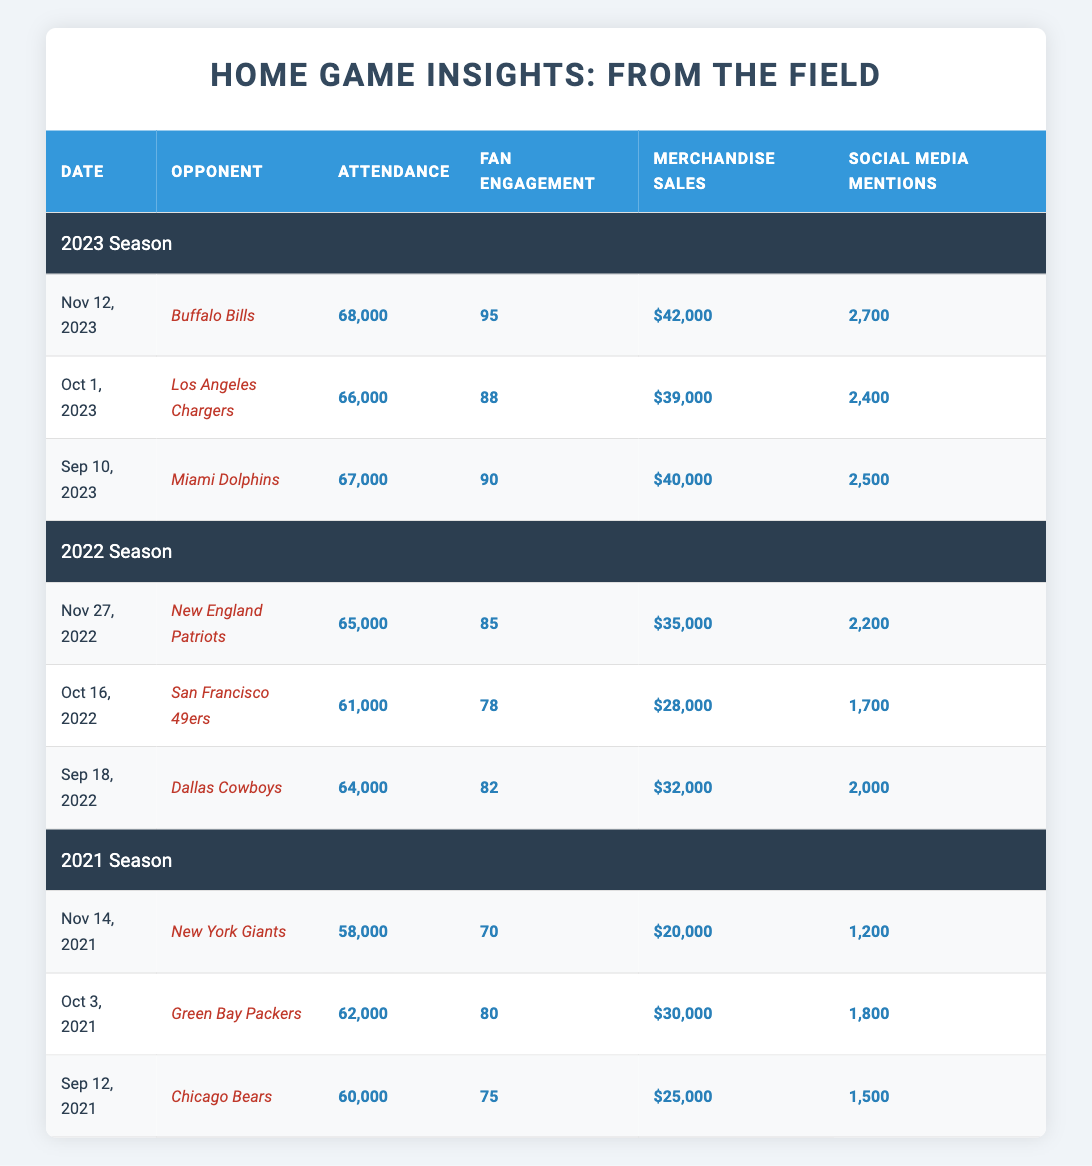What was the attendance for the game against the New England Patriots in 2022? The game against the New England Patriots in 2022 had an attendance of 65,000, as mentioned in the row corresponding to that game.
Answer: 65,000 Which opponent had the highest fan engagement score in 2023? The Buffalo Bills had the highest fan engagement score in 2023, with a score of 95, as seen in their row.
Answer: Buffalo Bills What is the average attendance for home games in the 2022 season? The total attendance for the 2022 season is (64,000 + 61,000 + 65,000) = 190,000 over 3 games. The average attendance is 190,000 / 3 = 63,333.33, which rounds to approximately 63,333.
Answer: 63,333 Did attendance increase from the 2021 season to the 2023 season? Yes, the average attendance in 2021 was 60,000, while in 2023, the average was 68,333, indicating an increase.
Answer: Yes Which season had the lowest merchandise sales? In the 2021 season, the merchandise sales were $20,000 for the game against the New York Giants, which were the lowest compared to other games in other seasons.
Answer: 2021 season What is the total merchandise sales for all home games in 2023? The merchandise sales for 2023 are $40,000 (Miami Dolphins) + $39,000 (Los Angeles Chargers) + $42,000 (Buffalo Bills) = $121,000.
Answer: $121,000 How many social media mentions were recorded for the Chicago Bears game in 2021? The social media mentions for the Chicago Bears game on September 12, 2021, were 1,500, as noted in that row.
Answer: 1,500 What is the difference in fan engagement scores between the highest and lowest games in the 2022 season? The highest score in 2022 was 85 (New England Patriots), and the lowest was 78 (San Francisco 49ers). The difference is 85 - 78 = 7.
Answer: 7 Did the attendance increase in every game from the 2021 season to the 2022 season? No, in 2022 the attendance for the game against the San Francisco 49ers was 61,000, which was lower than the attendance of 62,000 against the Green Bay Packers in 2021.
Answer: No Which game had the most social media mentions in the table? The game on November 12, 2023, against the Buffalo Bills had the most social media mentions with a total of 2,700.
Answer: Buffalo Bills game on Nov 12, 2023 